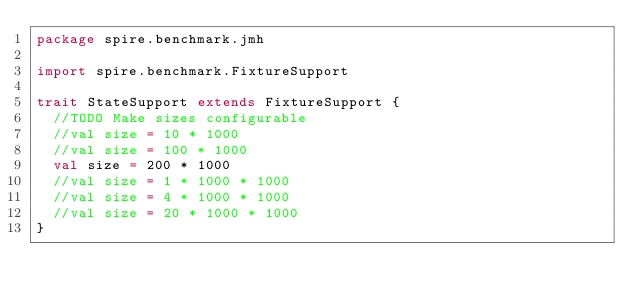Convert code to text. <code><loc_0><loc_0><loc_500><loc_500><_Scala_>package spire.benchmark.jmh

import spire.benchmark.FixtureSupport

trait StateSupport extends FixtureSupport {
  //TODO Make sizes configurable
  //val size = 10 * 1000
  //val size = 100 * 1000
  val size = 200 * 1000
  //val size = 1 * 1000 * 1000
  //val size = 4 * 1000 * 1000
  //val size = 20 * 1000 * 1000
}
</code> 